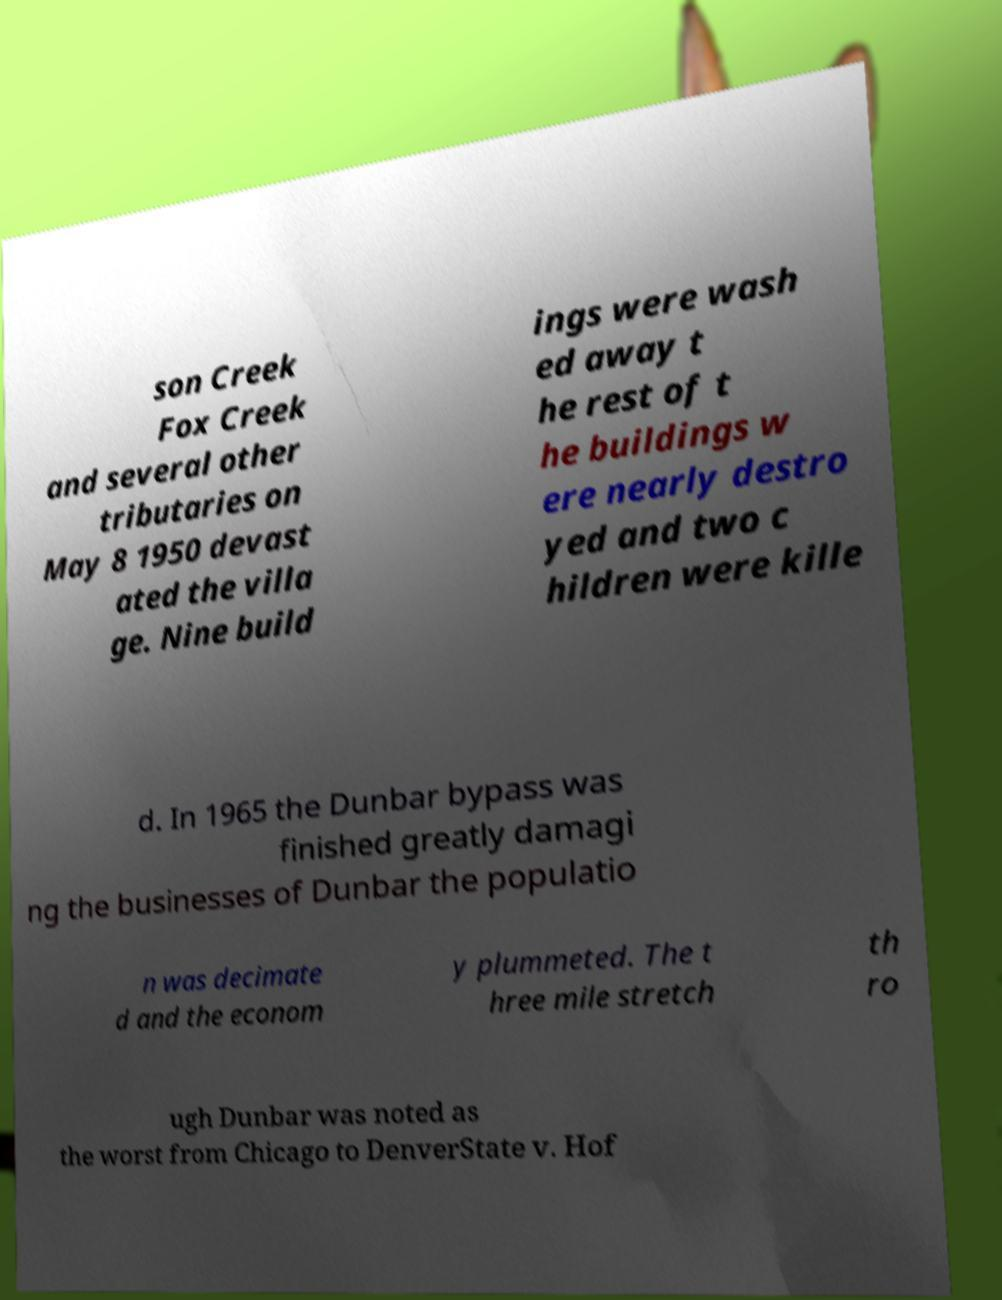Can you read and provide the text displayed in the image?This photo seems to have some interesting text. Can you extract and type it out for me? son Creek Fox Creek and several other tributaries on May 8 1950 devast ated the villa ge. Nine build ings were wash ed away t he rest of t he buildings w ere nearly destro yed and two c hildren were kille d. In 1965 the Dunbar bypass was finished greatly damagi ng the businesses of Dunbar the populatio n was decimate d and the econom y plummeted. The t hree mile stretch th ro ugh Dunbar was noted as the worst from Chicago to DenverState v. Hof 